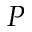Convert formula to latex. <formula><loc_0><loc_0><loc_500><loc_500>P</formula> 